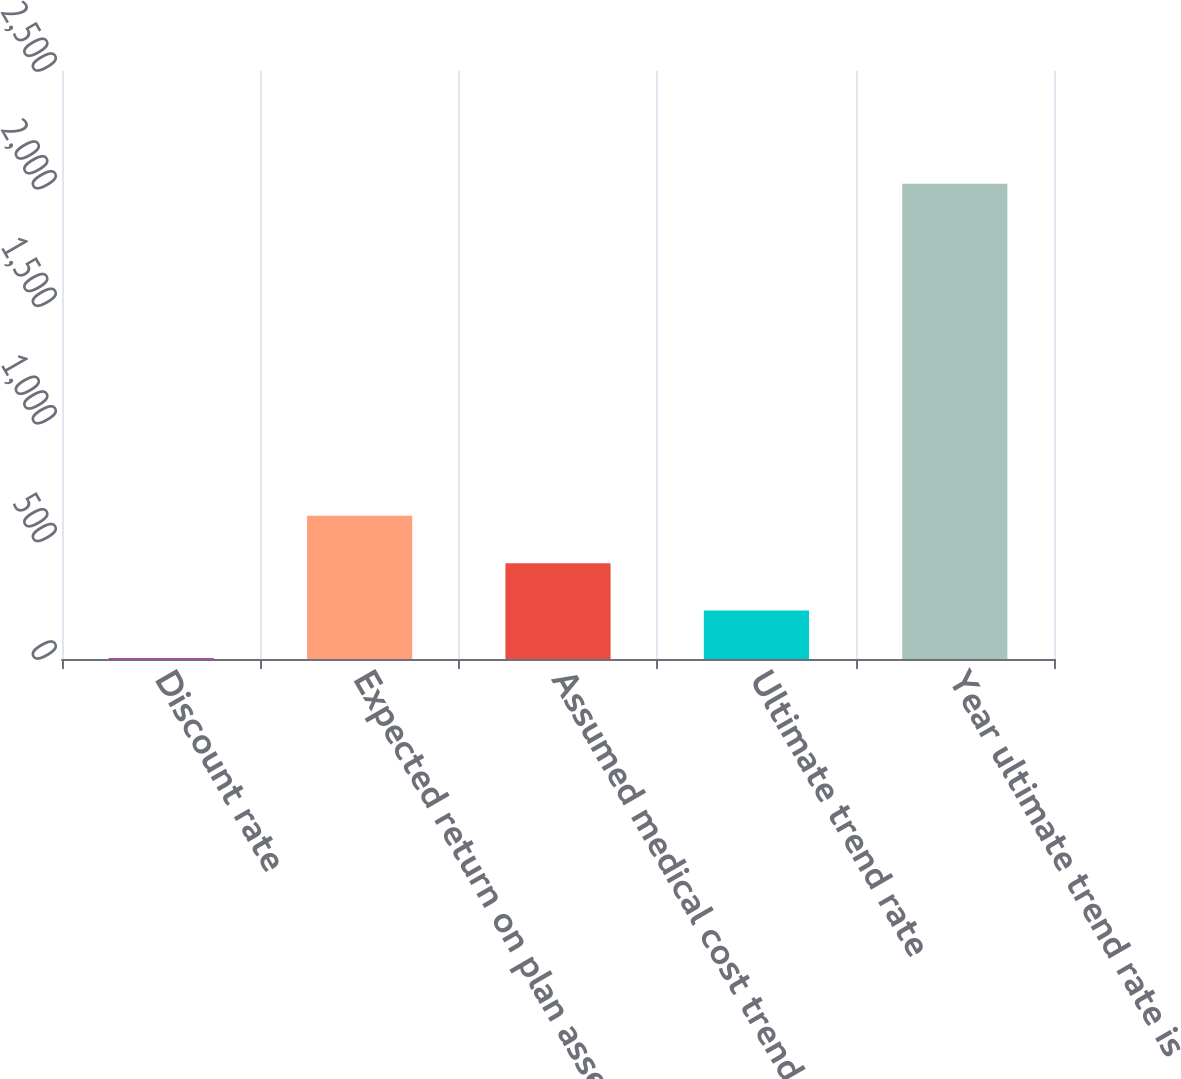<chart> <loc_0><loc_0><loc_500><loc_500><bar_chart><fcel>Discount rate<fcel>Expected return on plan assets<fcel>Assumed medical cost trend<fcel>Ultimate trend rate<fcel>Year ultimate trend rate is<nl><fcel>4.04<fcel>609.14<fcel>407.44<fcel>205.74<fcel>2021<nl></chart> 